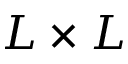<formula> <loc_0><loc_0><loc_500><loc_500>L \times L</formula> 